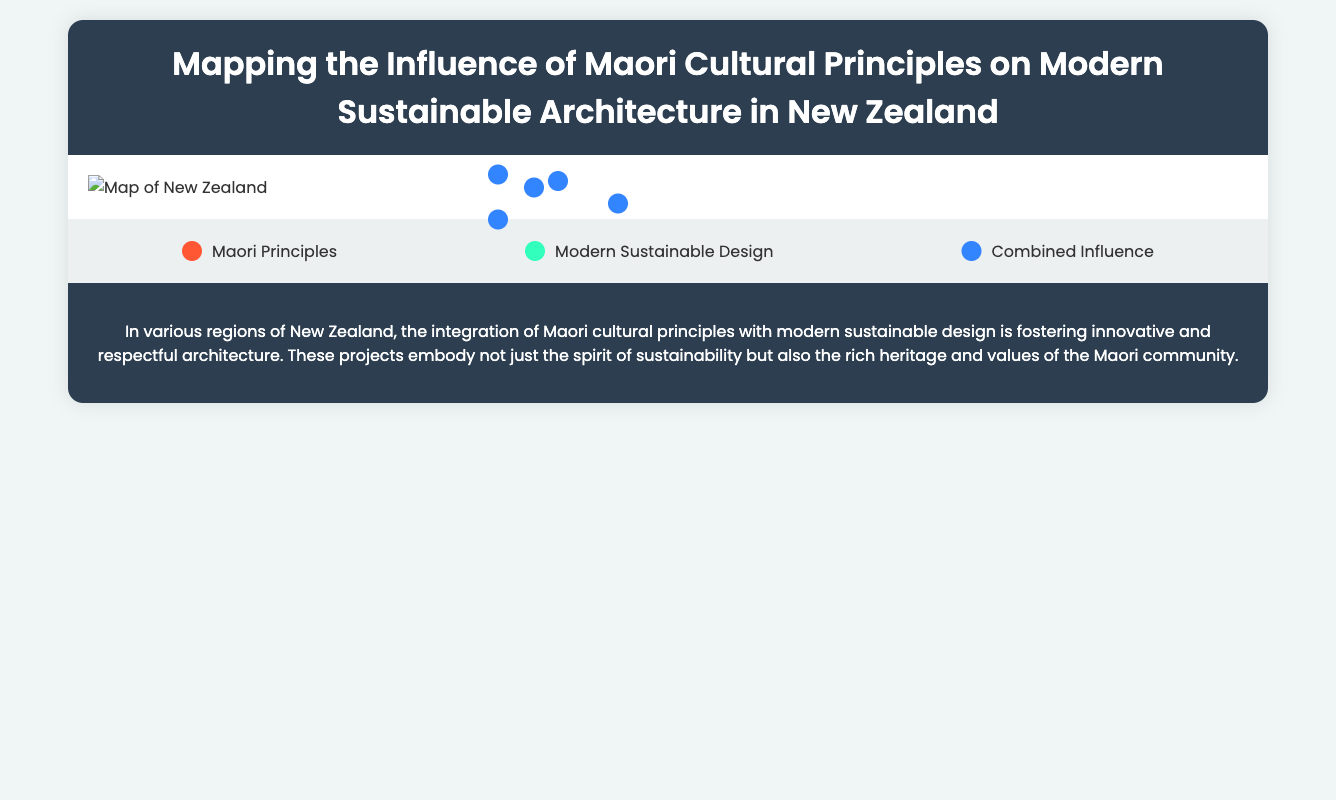What are the Maori principles highlighted in the Northland region? The Northland region showcases the Maori principles of Whakapapa and Manaakitanga in its architecture projects.
Answer: Whakapapa, Manaakitanga What sustainable features are present in the Waikato River Cleanup Trust HQ? The Waikato River Cleanup Trust HQ incorporates Greywater systems and local timber use as sustainable features.
Answer: Greywater systems, local timber use Which region features the Te Papa Tongarewa Museum? This museum is located in the Wellington region, showcasing Maori cultural principles in its design.
Answer: Wellington How many projects are listed under Auckland? There are two significant architecture projects listed under the Auckland region.
Answer: 2 What sustainable feature is common in the projects from Southland? A common sustainable feature in Southland projects is the implementation of wind power in project designs.
Answer: Wind power What Maori principle is associated with the Hamilton Gardens in Waikato? The Hamilton Gardens incorporates the Maori principle of Maramatanga, which guides its design.
Answer: Maramatanga In which region is the Baylys Beach Community Hall located? The Baylys Beach Community Hall is found in the Northland region of New Zealand.
Answer: Northland What conclusion is drawn about modern sustainable design in New Zealand? The conclusion reflects that modern sustainable design in New Zealand respects and embodies Maori cultural principles within architecture.
Answer: Innovative and respectful architecture What type of architecture is represented by Ngāti Whātua Ōrākei Marae? The Ngāti Whātua Ōrākei Marae represents modern sustainable architecture influenced by Maori cultural principles.
Answer: Modern sustainable architecture 